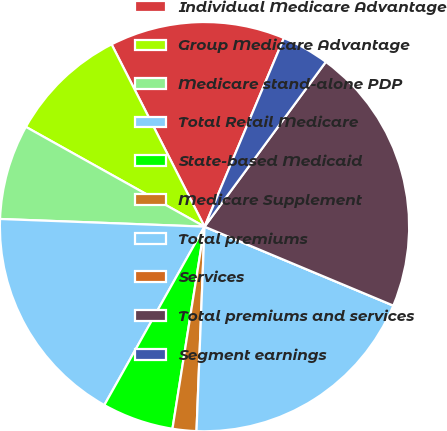<chart> <loc_0><loc_0><loc_500><loc_500><pie_chart><fcel>Individual Medicare Advantage<fcel>Group Medicare Advantage<fcel>Medicare stand-alone PDP<fcel>Total Retail Medicare<fcel>State-based Medicaid<fcel>Medicare Supplement<fcel>Total premiums<fcel>Services<fcel>Total premiums and services<fcel>Segment earnings<nl><fcel>13.84%<fcel>9.39%<fcel>7.51%<fcel>17.45%<fcel>5.64%<fcel>1.88%<fcel>19.32%<fcel>0.0%<fcel>21.2%<fcel>3.76%<nl></chart> 